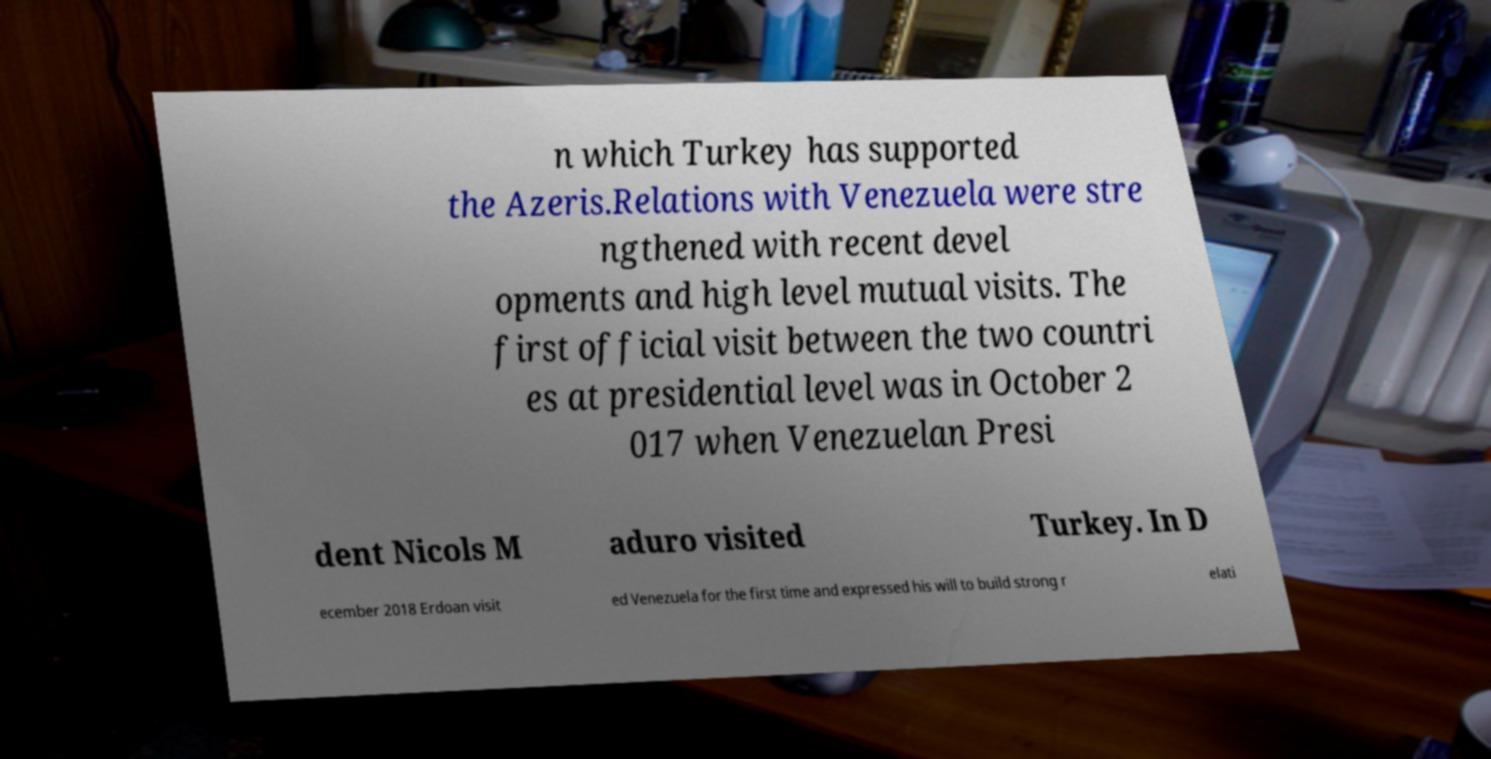Please read and relay the text visible in this image. What does it say? n which Turkey has supported the Azeris.Relations with Venezuela were stre ngthened with recent devel opments and high level mutual visits. The first official visit between the two countri es at presidential level was in October 2 017 when Venezuelan Presi dent Nicols M aduro visited Turkey. In D ecember 2018 Erdoan visit ed Venezuela for the first time and expressed his will to build strong r elati 